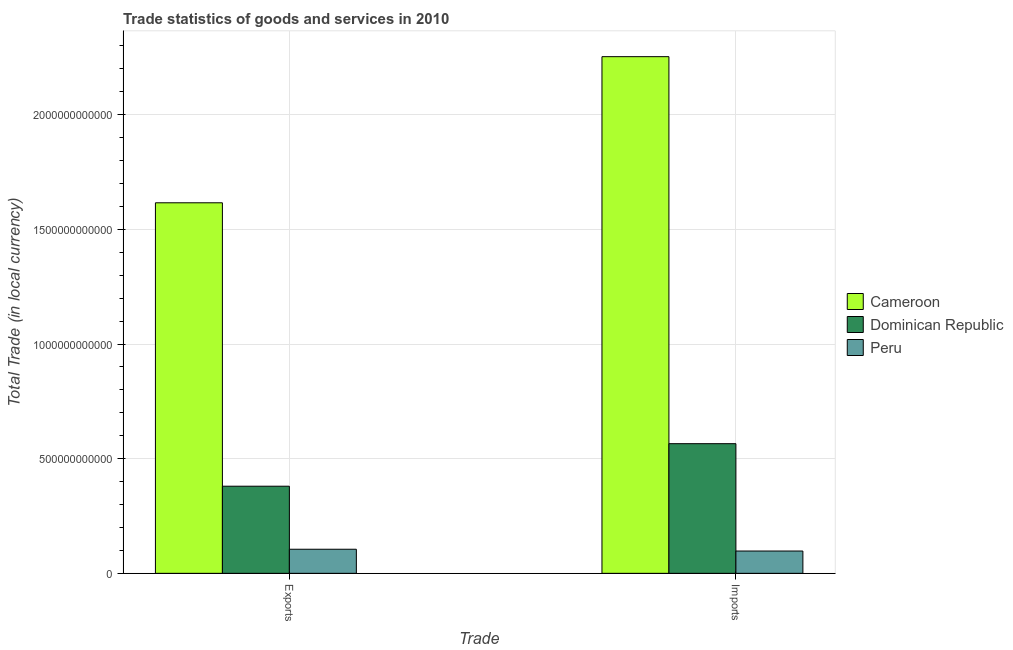How many groups of bars are there?
Offer a terse response. 2. Are the number of bars per tick equal to the number of legend labels?
Offer a terse response. Yes. How many bars are there on the 2nd tick from the right?
Offer a terse response. 3. What is the label of the 1st group of bars from the left?
Provide a short and direct response. Exports. What is the imports of goods and services in Peru?
Your response must be concise. 9.73e+1. Across all countries, what is the maximum export of goods and services?
Offer a terse response. 1.62e+12. Across all countries, what is the minimum imports of goods and services?
Your answer should be very brief. 9.73e+1. In which country was the export of goods and services maximum?
Provide a succinct answer. Cameroon. In which country was the imports of goods and services minimum?
Your answer should be compact. Peru. What is the total imports of goods and services in the graph?
Your answer should be very brief. 2.92e+12. What is the difference between the export of goods and services in Cameroon and that in Dominican Republic?
Ensure brevity in your answer.  1.24e+12. What is the difference between the export of goods and services in Peru and the imports of goods and services in Cameroon?
Make the answer very short. -2.15e+12. What is the average export of goods and services per country?
Provide a short and direct response. 7.00e+11. What is the difference between the imports of goods and services and export of goods and services in Cameroon?
Offer a terse response. 6.37e+11. In how many countries, is the export of goods and services greater than 900000000000 LCU?
Provide a succinct answer. 1. What is the ratio of the export of goods and services in Dominican Republic to that in Peru?
Provide a short and direct response. 3.62. In how many countries, is the export of goods and services greater than the average export of goods and services taken over all countries?
Your response must be concise. 1. What does the 2nd bar from the left in Exports represents?
Keep it short and to the point. Dominican Republic. What does the 2nd bar from the right in Imports represents?
Keep it short and to the point. Dominican Republic. How many bars are there?
Your answer should be very brief. 6. Are all the bars in the graph horizontal?
Your response must be concise. No. How many countries are there in the graph?
Offer a very short reply. 3. What is the difference between two consecutive major ticks on the Y-axis?
Your answer should be compact. 5.00e+11. Does the graph contain grids?
Provide a short and direct response. Yes. Where does the legend appear in the graph?
Your response must be concise. Center right. How many legend labels are there?
Provide a short and direct response. 3. What is the title of the graph?
Your response must be concise. Trade statistics of goods and services in 2010. What is the label or title of the X-axis?
Your answer should be very brief. Trade. What is the label or title of the Y-axis?
Offer a terse response. Total Trade (in local currency). What is the Total Trade (in local currency) in Cameroon in Exports?
Give a very brief answer. 1.62e+12. What is the Total Trade (in local currency) in Dominican Republic in Exports?
Make the answer very short. 3.80e+11. What is the Total Trade (in local currency) in Peru in Exports?
Make the answer very short. 1.05e+11. What is the Total Trade (in local currency) of Cameroon in Imports?
Give a very brief answer. 2.25e+12. What is the Total Trade (in local currency) in Dominican Republic in Imports?
Your response must be concise. 5.65e+11. What is the Total Trade (in local currency) of Peru in Imports?
Offer a very short reply. 9.73e+1. Across all Trade, what is the maximum Total Trade (in local currency) of Cameroon?
Give a very brief answer. 2.25e+12. Across all Trade, what is the maximum Total Trade (in local currency) in Dominican Republic?
Provide a short and direct response. 5.65e+11. Across all Trade, what is the maximum Total Trade (in local currency) in Peru?
Give a very brief answer. 1.05e+11. Across all Trade, what is the minimum Total Trade (in local currency) of Cameroon?
Provide a short and direct response. 1.62e+12. Across all Trade, what is the minimum Total Trade (in local currency) in Dominican Republic?
Offer a very short reply. 3.80e+11. Across all Trade, what is the minimum Total Trade (in local currency) in Peru?
Offer a very short reply. 9.73e+1. What is the total Total Trade (in local currency) of Cameroon in the graph?
Provide a short and direct response. 3.87e+12. What is the total Total Trade (in local currency) in Dominican Republic in the graph?
Offer a terse response. 9.45e+11. What is the total Total Trade (in local currency) in Peru in the graph?
Give a very brief answer. 2.02e+11. What is the difference between the Total Trade (in local currency) in Cameroon in Exports and that in Imports?
Provide a succinct answer. -6.37e+11. What is the difference between the Total Trade (in local currency) in Dominican Republic in Exports and that in Imports?
Make the answer very short. -1.85e+11. What is the difference between the Total Trade (in local currency) of Peru in Exports and that in Imports?
Give a very brief answer. 7.73e+09. What is the difference between the Total Trade (in local currency) in Cameroon in Exports and the Total Trade (in local currency) in Dominican Republic in Imports?
Provide a succinct answer. 1.05e+12. What is the difference between the Total Trade (in local currency) of Cameroon in Exports and the Total Trade (in local currency) of Peru in Imports?
Keep it short and to the point. 1.52e+12. What is the difference between the Total Trade (in local currency) of Dominican Republic in Exports and the Total Trade (in local currency) of Peru in Imports?
Make the answer very short. 2.83e+11. What is the average Total Trade (in local currency) of Cameroon per Trade?
Your answer should be very brief. 1.93e+12. What is the average Total Trade (in local currency) of Dominican Republic per Trade?
Provide a short and direct response. 4.73e+11. What is the average Total Trade (in local currency) in Peru per Trade?
Give a very brief answer. 1.01e+11. What is the difference between the Total Trade (in local currency) in Cameroon and Total Trade (in local currency) in Dominican Republic in Exports?
Keep it short and to the point. 1.24e+12. What is the difference between the Total Trade (in local currency) in Cameroon and Total Trade (in local currency) in Peru in Exports?
Provide a short and direct response. 1.51e+12. What is the difference between the Total Trade (in local currency) of Dominican Republic and Total Trade (in local currency) of Peru in Exports?
Offer a terse response. 2.75e+11. What is the difference between the Total Trade (in local currency) in Cameroon and Total Trade (in local currency) in Dominican Republic in Imports?
Offer a terse response. 1.69e+12. What is the difference between the Total Trade (in local currency) in Cameroon and Total Trade (in local currency) in Peru in Imports?
Make the answer very short. 2.16e+12. What is the difference between the Total Trade (in local currency) in Dominican Republic and Total Trade (in local currency) in Peru in Imports?
Provide a succinct answer. 4.68e+11. What is the ratio of the Total Trade (in local currency) in Cameroon in Exports to that in Imports?
Offer a terse response. 0.72. What is the ratio of the Total Trade (in local currency) of Dominican Republic in Exports to that in Imports?
Your answer should be very brief. 0.67. What is the ratio of the Total Trade (in local currency) of Peru in Exports to that in Imports?
Offer a very short reply. 1.08. What is the difference between the highest and the second highest Total Trade (in local currency) of Cameroon?
Offer a terse response. 6.37e+11. What is the difference between the highest and the second highest Total Trade (in local currency) of Dominican Republic?
Make the answer very short. 1.85e+11. What is the difference between the highest and the second highest Total Trade (in local currency) of Peru?
Your response must be concise. 7.73e+09. What is the difference between the highest and the lowest Total Trade (in local currency) of Cameroon?
Keep it short and to the point. 6.37e+11. What is the difference between the highest and the lowest Total Trade (in local currency) in Dominican Republic?
Provide a short and direct response. 1.85e+11. What is the difference between the highest and the lowest Total Trade (in local currency) of Peru?
Offer a very short reply. 7.73e+09. 